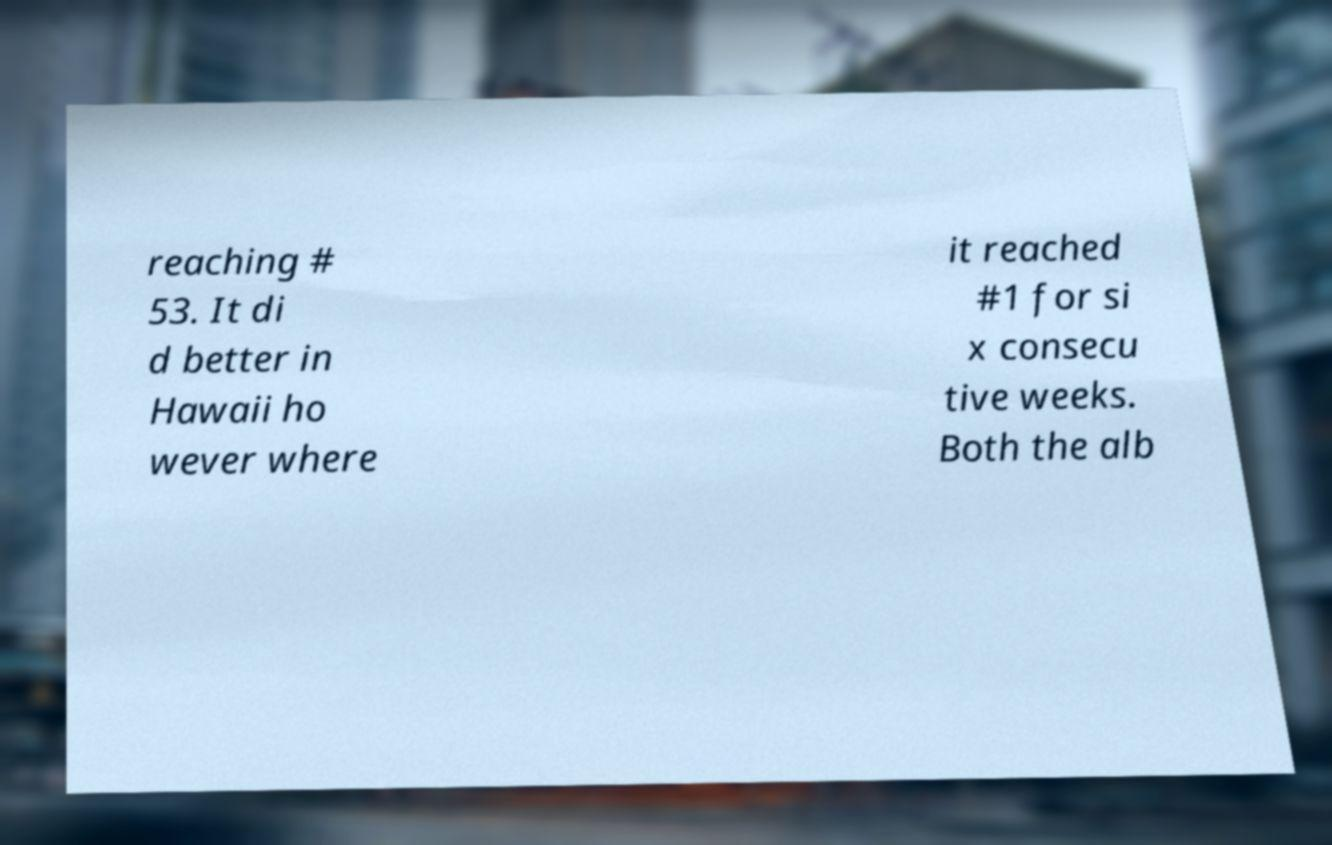What messages or text are displayed in this image? I need them in a readable, typed format. reaching # 53. It di d better in Hawaii ho wever where it reached #1 for si x consecu tive weeks. Both the alb 